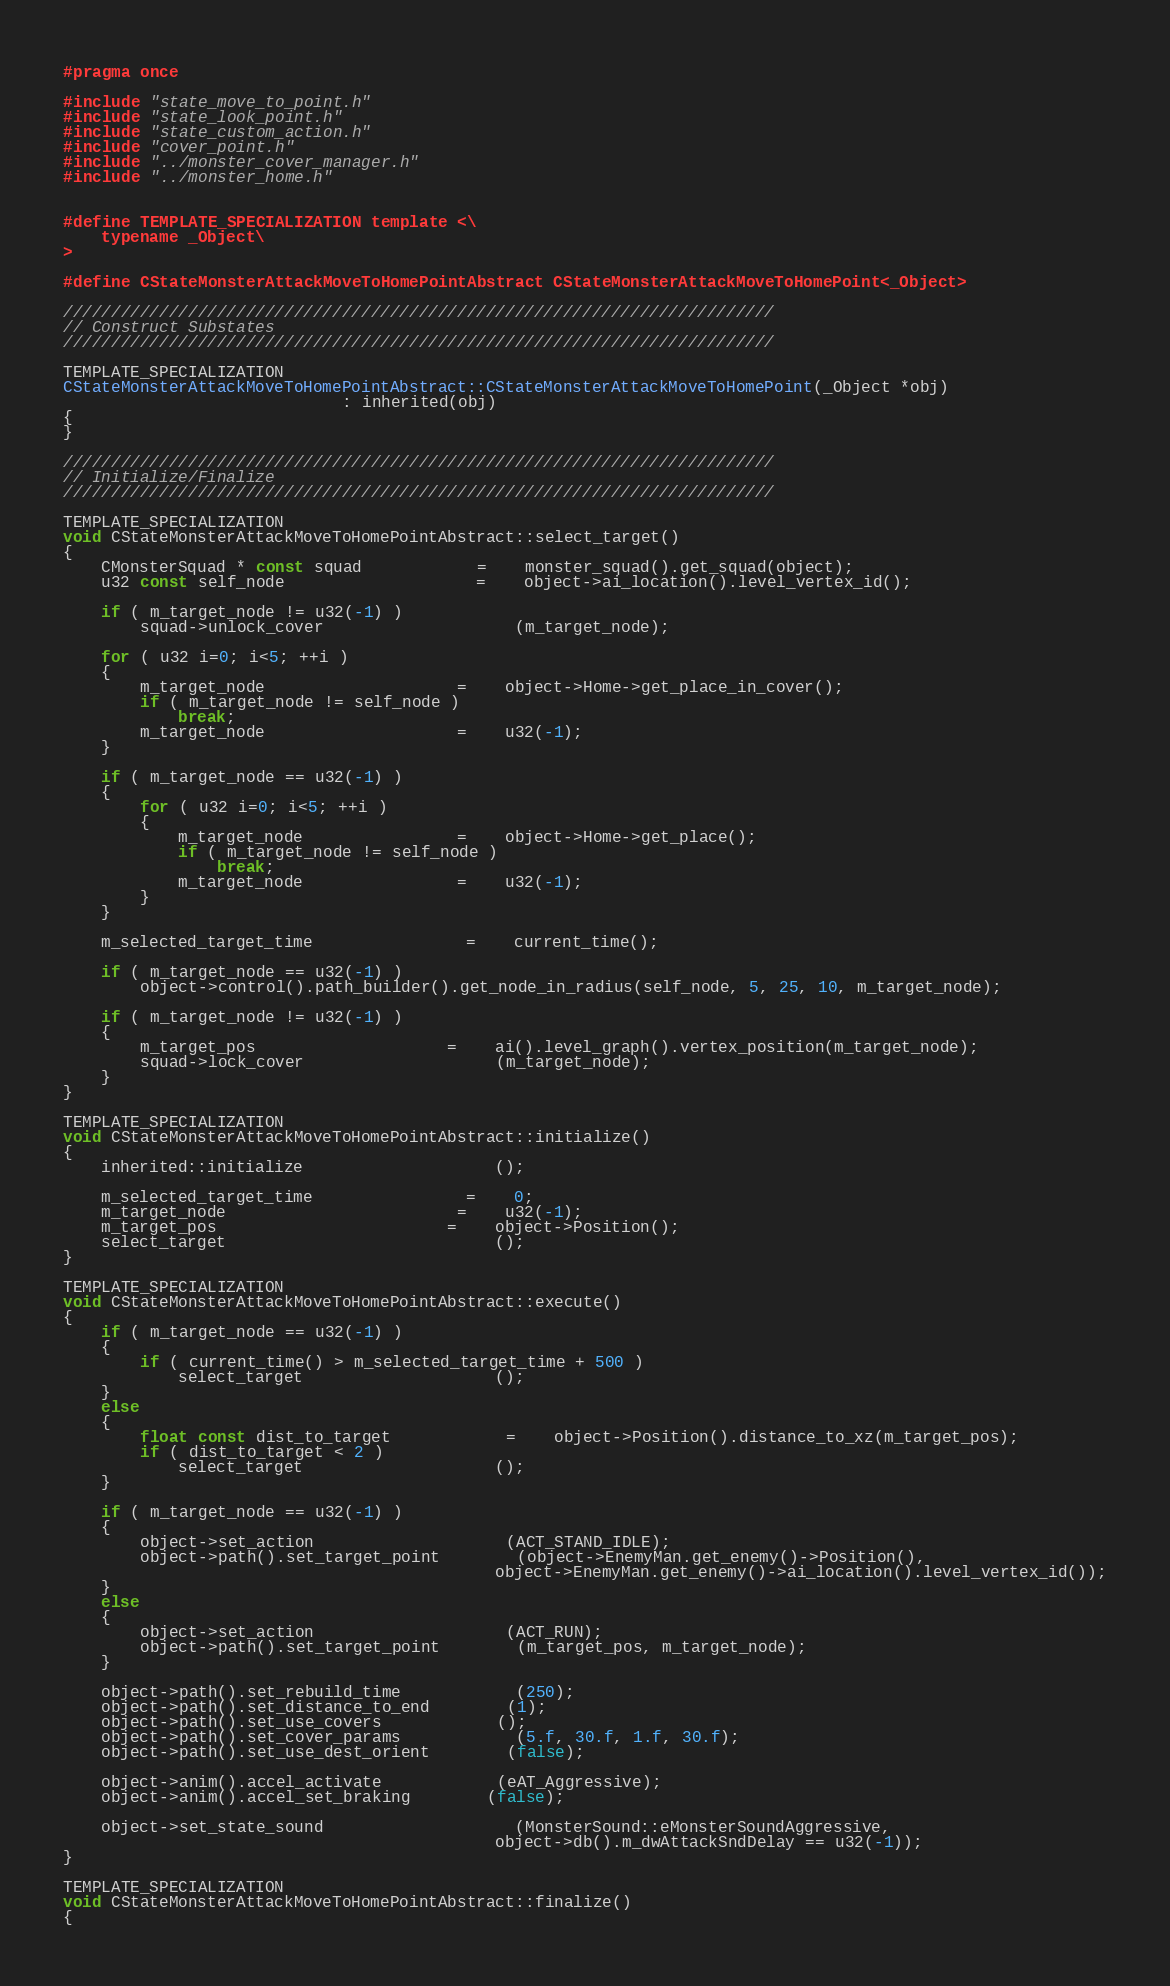Convert code to text. <code><loc_0><loc_0><loc_500><loc_500><_C_>#pragma once

#include "state_move_to_point.h"
#include "state_look_point.h"
#include "state_custom_action.h"
#include "cover_point.h"
#include "../monster_cover_manager.h"
#include "../monster_home.h"


#define TEMPLATE_SPECIALIZATION template <\
	typename _Object\
>

#define CStateMonsterAttackMoveToHomePointAbstract CStateMonsterAttackMoveToHomePoint<_Object>

//////////////////////////////////////////////////////////////////////////
// Construct Substates
//////////////////////////////////////////////////////////////////////////

TEMPLATE_SPECIALIZATION
CStateMonsterAttackMoveToHomePointAbstract::CStateMonsterAttackMoveToHomePoint(_Object *obj) 
                             : inherited(obj)
{
}

//////////////////////////////////////////////////////////////////////////
// Initialize/Finalize
//////////////////////////////////////////////////////////////////////////

TEMPLATE_SPECIALIZATION
void CStateMonsterAttackMoveToHomePointAbstract::select_target()
{
	CMonsterSquad * const squad			=	monster_squad().get_squad(object);
	u32 const self_node					=	object->ai_location().level_vertex_id();

	if ( m_target_node != u32(-1) )
		squad->unlock_cover					(m_target_node);

	for ( u32 i=0; i<5; ++i )
	{
		m_target_node					=	object->Home->get_place_in_cover();
		if ( m_target_node != self_node )
			break;
		m_target_node					=	u32(-1);
	}

	if ( m_target_node == u32(-1) ) 
	{
		for ( u32 i=0; i<5; ++i )
		{
			m_target_node				=	object->Home->get_place();
			if ( m_target_node != self_node )
				break;
			m_target_node				=	u32(-1);
		}
	}

	m_selected_target_time				=	current_time();

	if ( m_target_node == u32(-1) )
		object->control().path_builder().get_node_in_radius(self_node, 5, 25, 10, m_target_node);

	if ( m_target_node != u32(-1) )
	{
		m_target_pos					=	ai().level_graph().vertex_position(m_target_node);
		squad->lock_cover					(m_target_node);
	}
}

TEMPLATE_SPECIALIZATION
void CStateMonsterAttackMoveToHomePointAbstract::initialize()
{
	inherited::initialize					();

	m_selected_target_time				=	0;
	m_target_node						=	u32(-1);
	m_target_pos						=	object->Position();
	select_target							();
}

TEMPLATE_SPECIALIZATION
void CStateMonsterAttackMoveToHomePointAbstract::execute()
{
	if ( m_target_node == u32(-1) )
	{
		if ( current_time() > m_selected_target_time + 500 )
			select_target					();
	}
	else
	{
		float const dist_to_target			=	object->Position().distance_to_xz(m_target_pos);
		if ( dist_to_target < 2 )
			select_target					();
	}

	if ( m_target_node == u32(-1) )
	{
		object->set_action					(ACT_STAND_IDLE);
		object->path().set_target_point		(object->EnemyMan.get_enemy()->Position(), 
											 object->EnemyMan.get_enemy()->ai_location().level_vertex_id());
	}
	else
	{
		object->set_action					(ACT_RUN);
		object->path().set_target_point		(m_target_pos, m_target_node);
	}

	object->path().set_rebuild_time			(250);
	object->path().set_distance_to_end		(1);
	object->path().set_use_covers			();
	object->path().set_cover_params			(5.f, 30.f, 1.f, 30.f);
	object->path().set_use_dest_orient		(false);

	object->anim().accel_activate			(eAT_Aggressive);
	object->anim().accel_set_braking		(false);

	object->set_state_sound					(MonsterSound::eMonsterSoundAggressive, 
											 object->db().m_dwAttackSndDelay == u32(-1));
}

TEMPLATE_SPECIALIZATION
void CStateMonsterAttackMoveToHomePointAbstract::finalize()
{</code> 